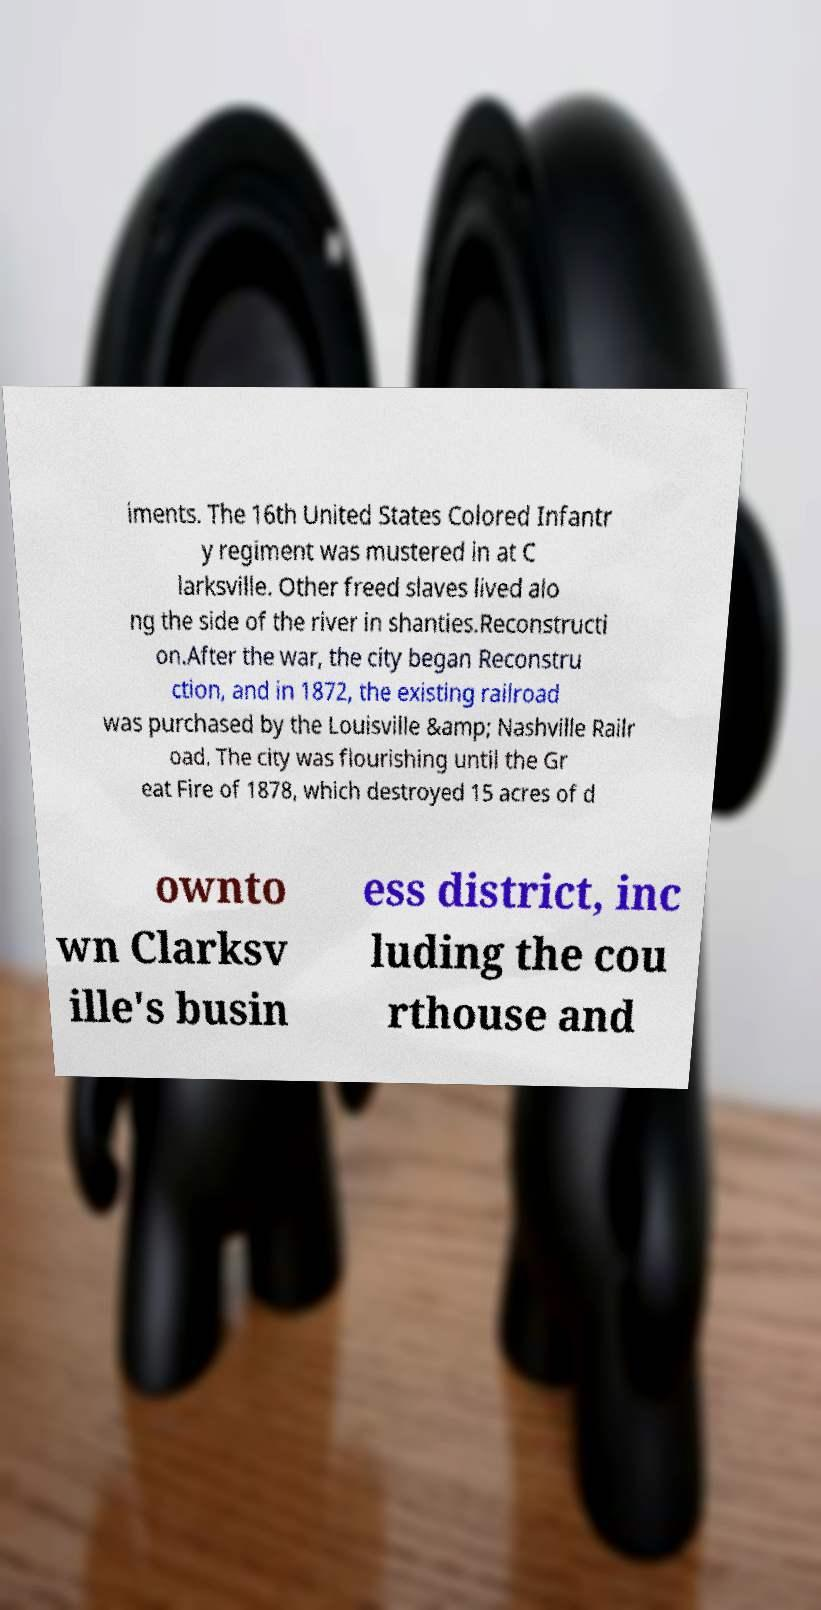I need the written content from this picture converted into text. Can you do that? iments. The 16th United States Colored Infantr y regiment was mustered in at C larksville. Other freed slaves lived alo ng the side of the river in shanties.Reconstructi on.After the war, the city began Reconstru ction, and in 1872, the existing railroad was purchased by the Louisville &amp; Nashville Railr oad. The city was flourishing until the Gr eat Fire of 1878, which destroyed 15 acres of d ownto wn Clarksv ille's busin ess district, inc luding the cou rthouse and 